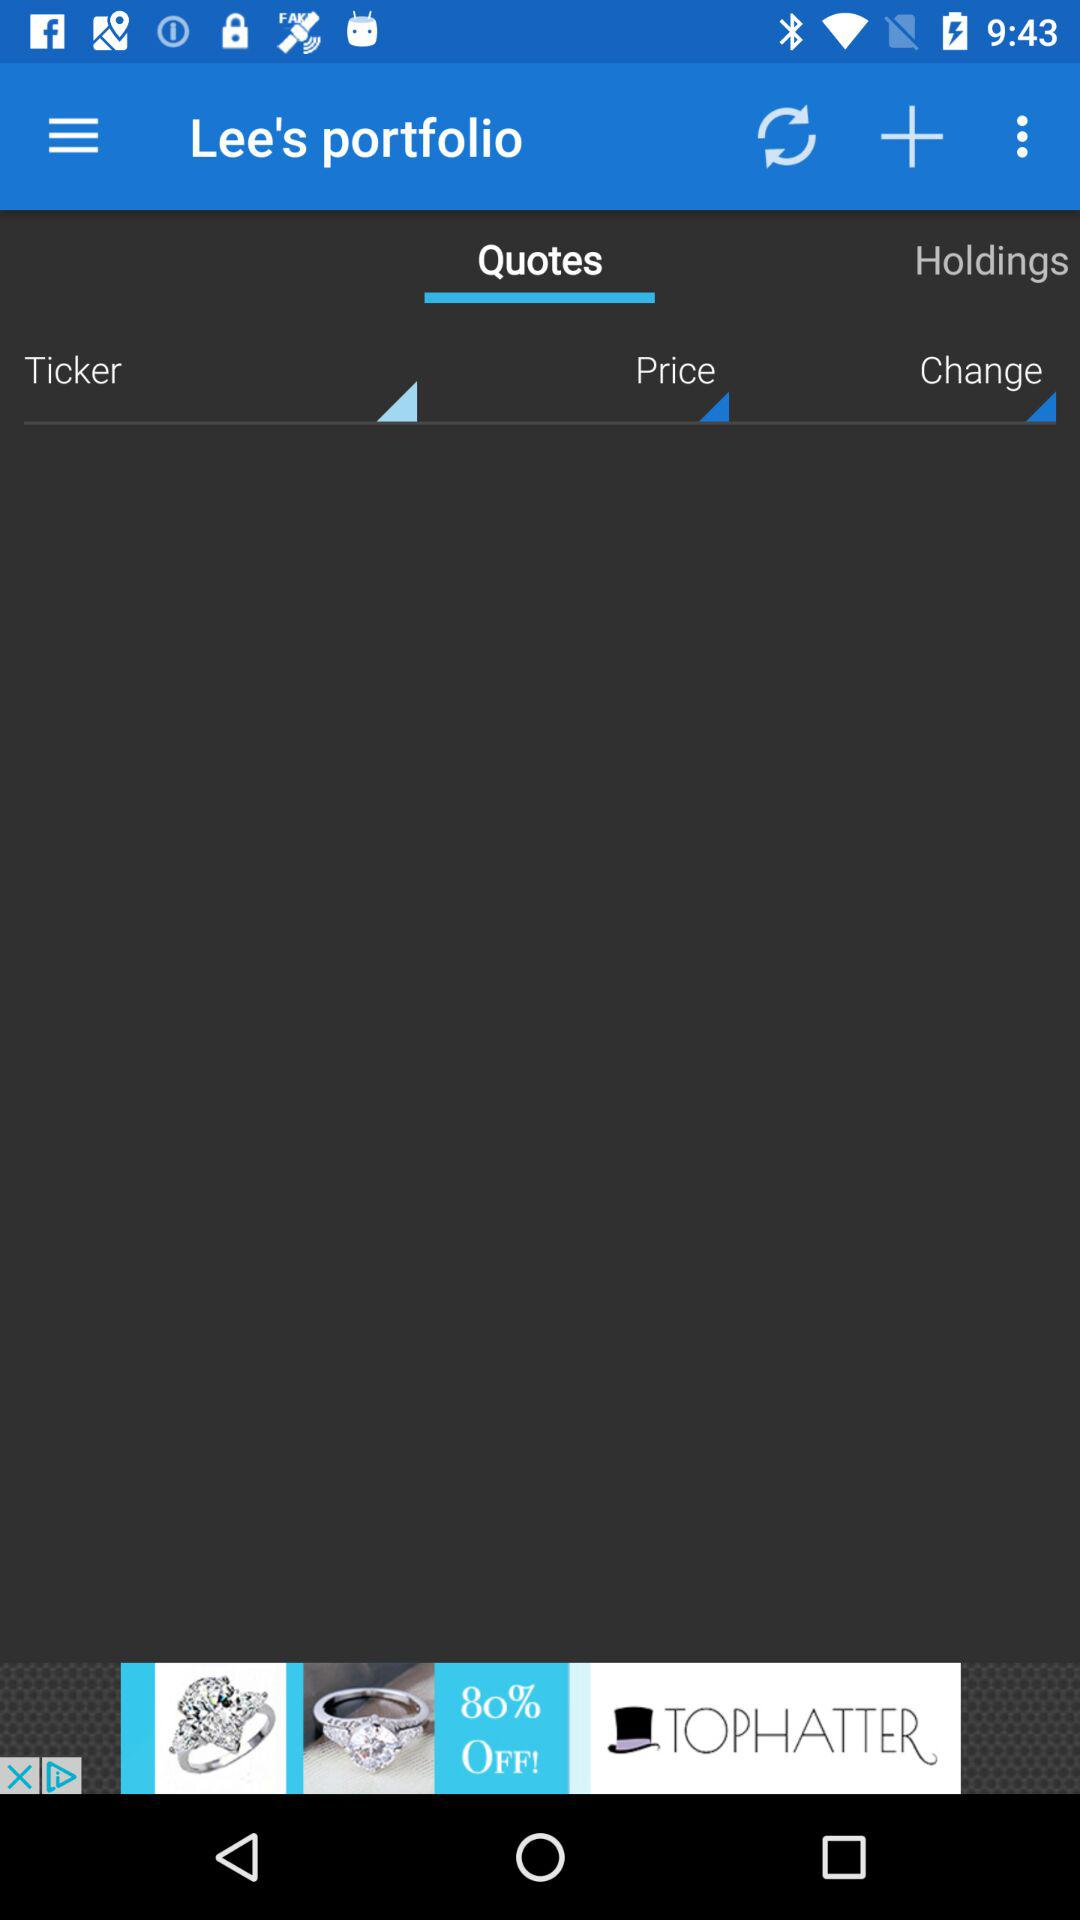Which tab is selected? The selected tab is "Quotes". 